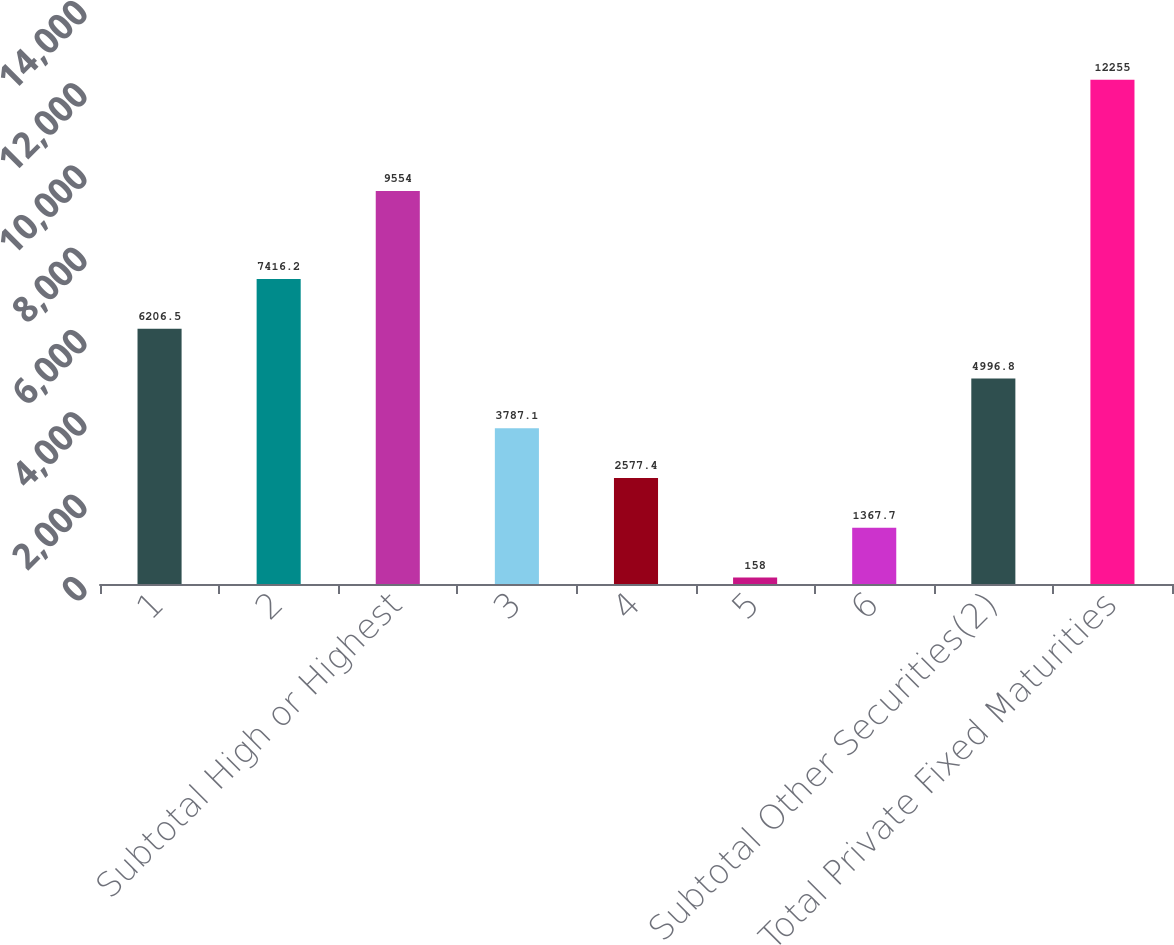Convert chart to OTSL. <chart><loc_0><loc_0><loc_500><loc_500><bar_chart><fcel>1<fcel>2<fcel>Subtotal High or Highest<fcel>3<fcel>4<fcel>5<fcel>6<fcel>Subtotal Other Securities(2)<fcel>Total Private Fixed Maturities<nl><fcel>6206.5<fcel>7416.2<fcel>9554<fcel>3787.1<fcel>2577.4<fcel>158<fcel>1367.7<fcel>4996.8<fcel>12255<nl></chart> 